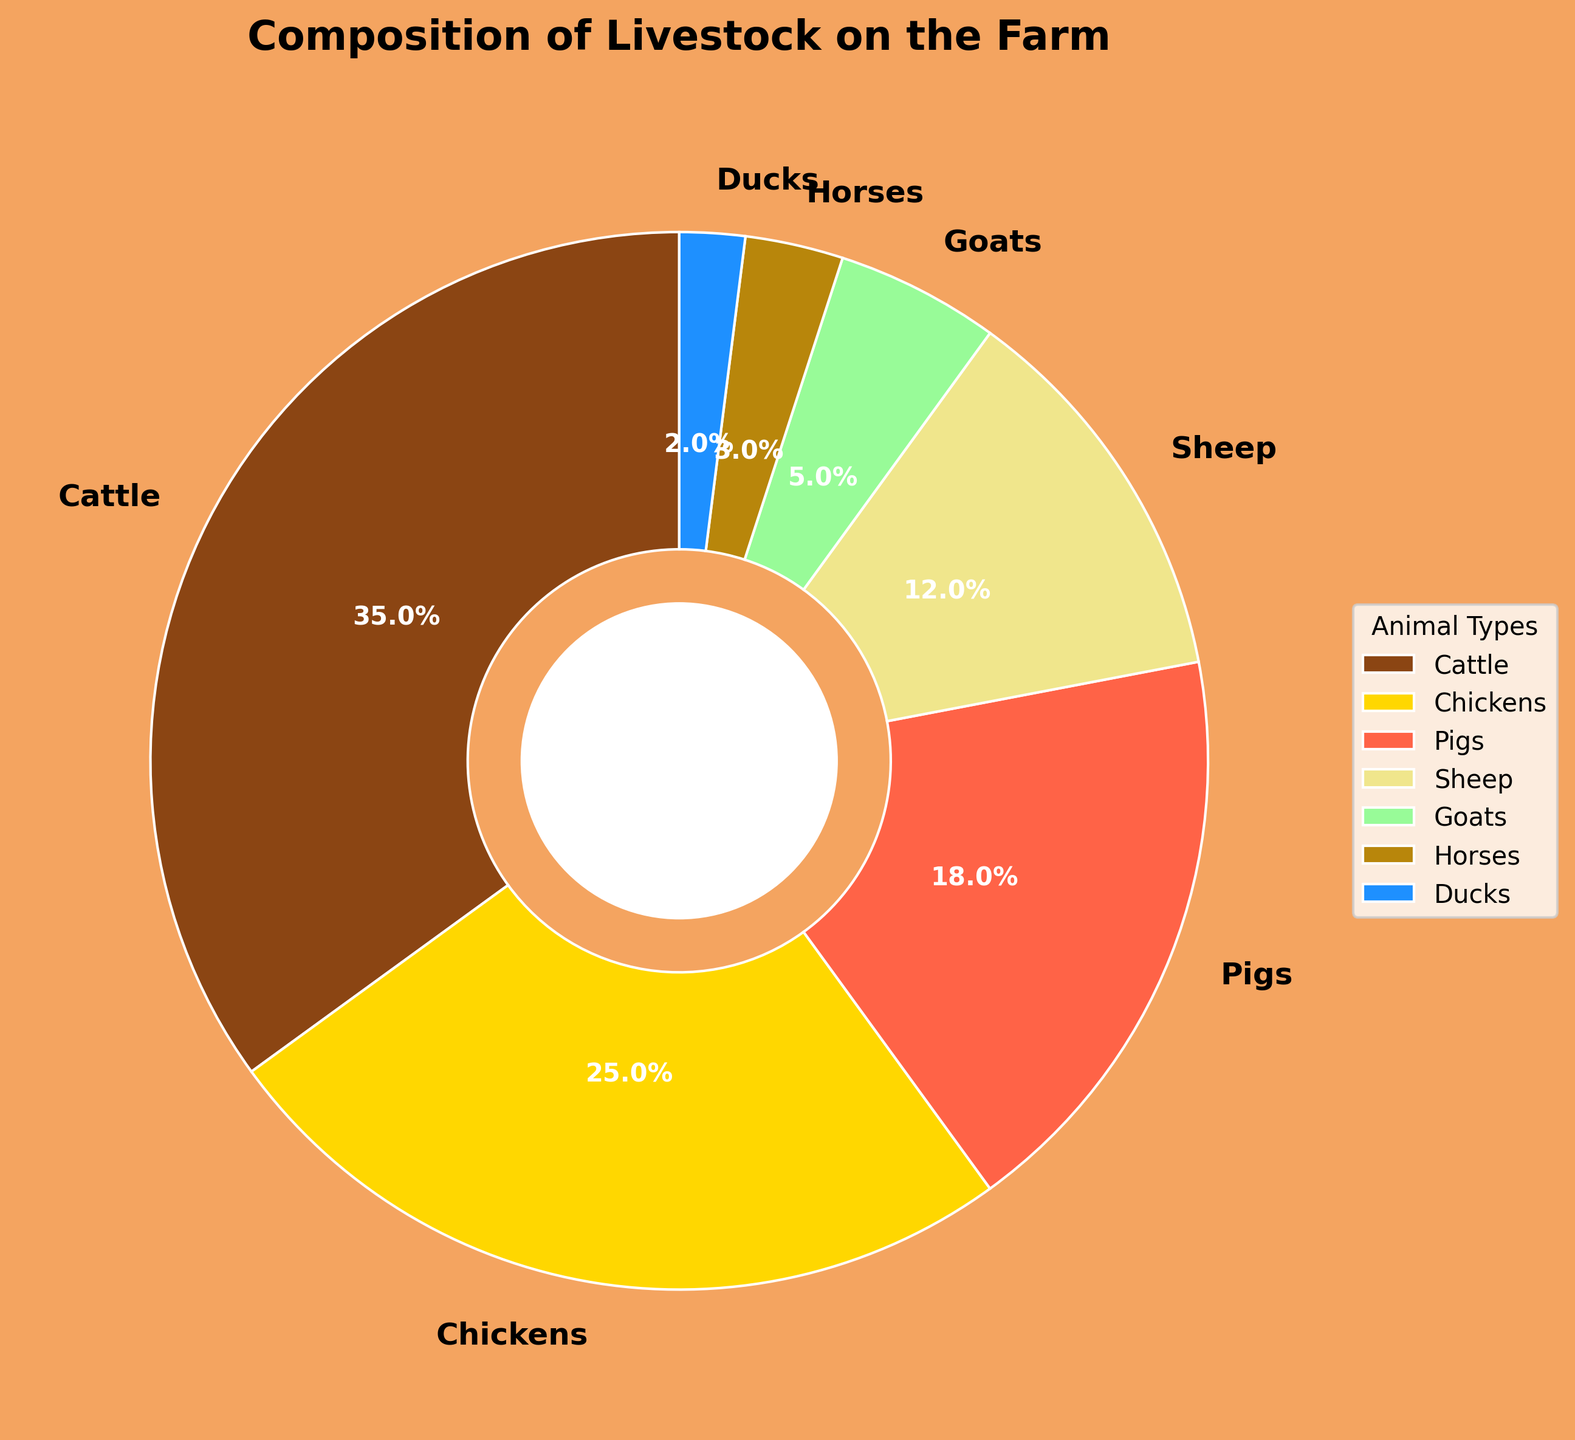What's the combined percentage of Cattle, Sheep, and Goats? To find the combined percentage, we add the individual percentages of Cattle (35%), Sheep (12%), and Goats (5%): 35 + 12 + 5 = 52
Answer: 52% Which type of livestock constitutes the smallest percentage of the total? By inspecting the chart, we see that Ducks have the smallest percentage of 2%.
Answer: Ducks What's the difference in percentage between Pigs and Chickens? The percentage for Pigs is 18% and for Chickens is 25%. The difference is 25 - 18 = 7
Answer: 7% Which animals together make up more than half of the livestock? Adding the percentages of the top animals until the sum exceeds 50%: Cattle (35%) + Chickens (25%) = 60%, which is more than 50%, so Cattle and Chickens together make up more than half
Answer: Cattle and Chickens How many animal types have less than 10% each? By checking the chart, we see that Goats (5%), Horses (3%), and Ducks (2%) each have less than 10%
Answer: 3 Which has a higher percentage, Sheep or Goats, and by how much? Sheep (12%) compared to Goats (5%): 12 - 5 = 7. Therefore, Sheep have a higher percentage by 7%
Answer: Sheep by 7% What color is used to represent Horses? The color used for Horses in the chart is a rustic brown/gold shade. The actual color would be identified visually.
Answer: Rustic brown/gold What percentage of the livestock are Chickens and how is it visually represented? Chickens make up 25% of the livestock, visually represented by a corresponding segment in the pie chart.
Answer: 25% If Ducks and Horses were combined into a single category, what would be their total percentage? Adding the percentages for Ducks (2%) and Horses (3%): 2 + 3 = 5
Answer: 5% What’s the average percentage of all animal types on the farm? Sum of percentages = 35 + 25 + 18 + 12 + 5 + 3 + 2 = 100. Number of types = 7. Average = 100 / 7 ≈ 14.3
Answer: 14.3% 